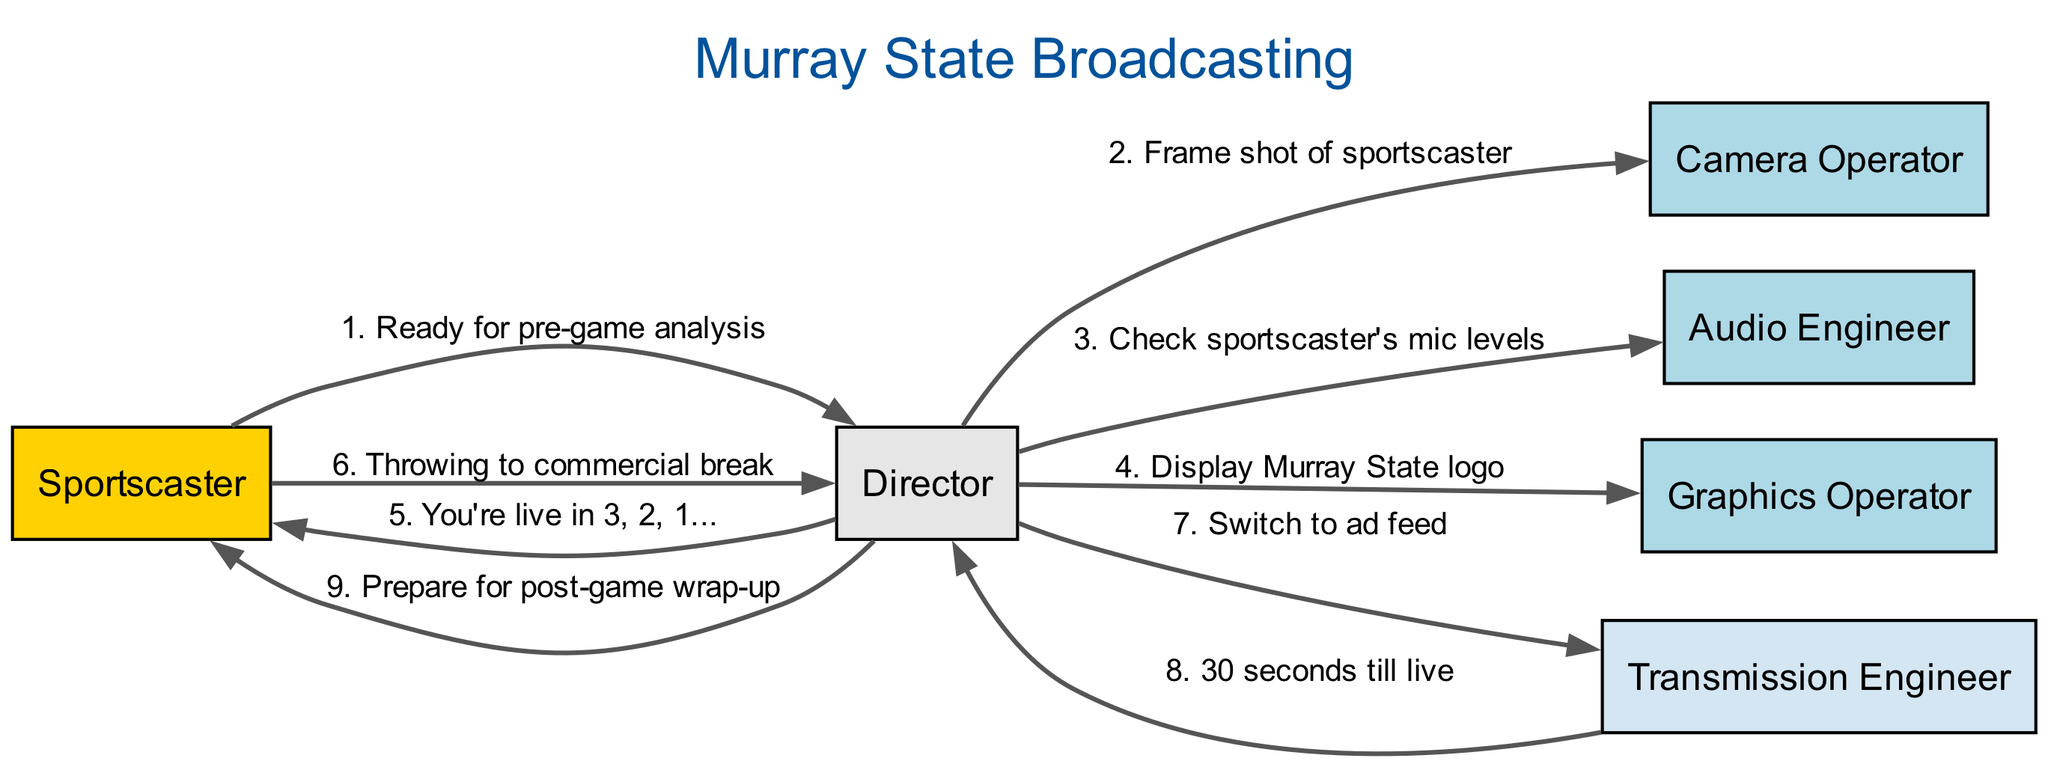What is the first message in the sequence? The first message is sent from the Sportscaster to the Director indicating readiness for pre-game analysis.
Answer: Ready for pre-game analysis How many actors are involved in this broadcasting workflow? By counting the actors listed in the diagram, we see there are six distinct roles mentioned: Sportscaster, Camera Operator, Director, Audio Engineer, Graphics Operator, and Transmission Engineer.
Answer: Six What message does the Director send to the Audio Engineer? The Director instructs the Audio Engineer to check the mic levels for the Sportscaster, as stated in the diagram.
Answer: Check sportscaster's mic levels Which actor receives the message "Prepare for post-game wrap-up"? The message "Prepare for post-game wrap-up" is directed to the Sportscaster from the Director, indicating the action plan moving forward.
Answer: Sportscaster What is the relationship between the Director and the Transmission Engineer in this workflow? The Director sends a message to the Transmission Engineer, asking them to switch to the ad feed, which indicates a coordination role in the broadcasting process.
Answer: Switch to ad feed How many total messages are exchanged in the diagram? We can count all the messages in the sequence, resulting in a total of eight messages exchanged among actors in the workflow.
Answer: Eight What is the last message sent in the sequence? The last message in the sequence is from the Director to the Sportscaster, directing preparation for the post-game wrap-up.
Answer: Prepare for post-game wrap-up Which actor is associated with the Murray State logo display? The Director is responsible for instructing the Graphics Operator to display the Murray State logo, highlighting the importance of branding in the broadcast.
Answer: Graphics Operator What is the timestamp mentioned by the Transmission Engineer? The Transmission Engineer mentions a countdown of "30 seconds till live," indicating the timing in the broadcasting sequence.
Answer: 30 seconds till live 